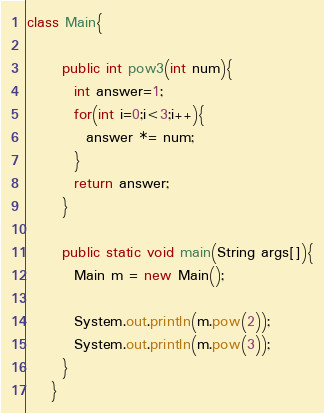<code> <loc_0><loc_0><loc_500><loc_500><_Java_>class Main{
    
	  public int pow3(int num){
	    int answer=1;
	    for(int i=0;i<3;i++){
	      answer *= num;
	    }
	    return answer;
	  }
	    
	  public static void main(String args[]){
	    Main m = new Main();
	  
	    System.out.println(m.pow(2));
	    System.out.println(m.pow(3));
	  }
	}</code> 